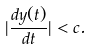Convert formula to latex. <formula><loc_0><loc_0><loc_500><loc_500>| \frac { d { y } ( t ) } { d t } | < c .</formula> 